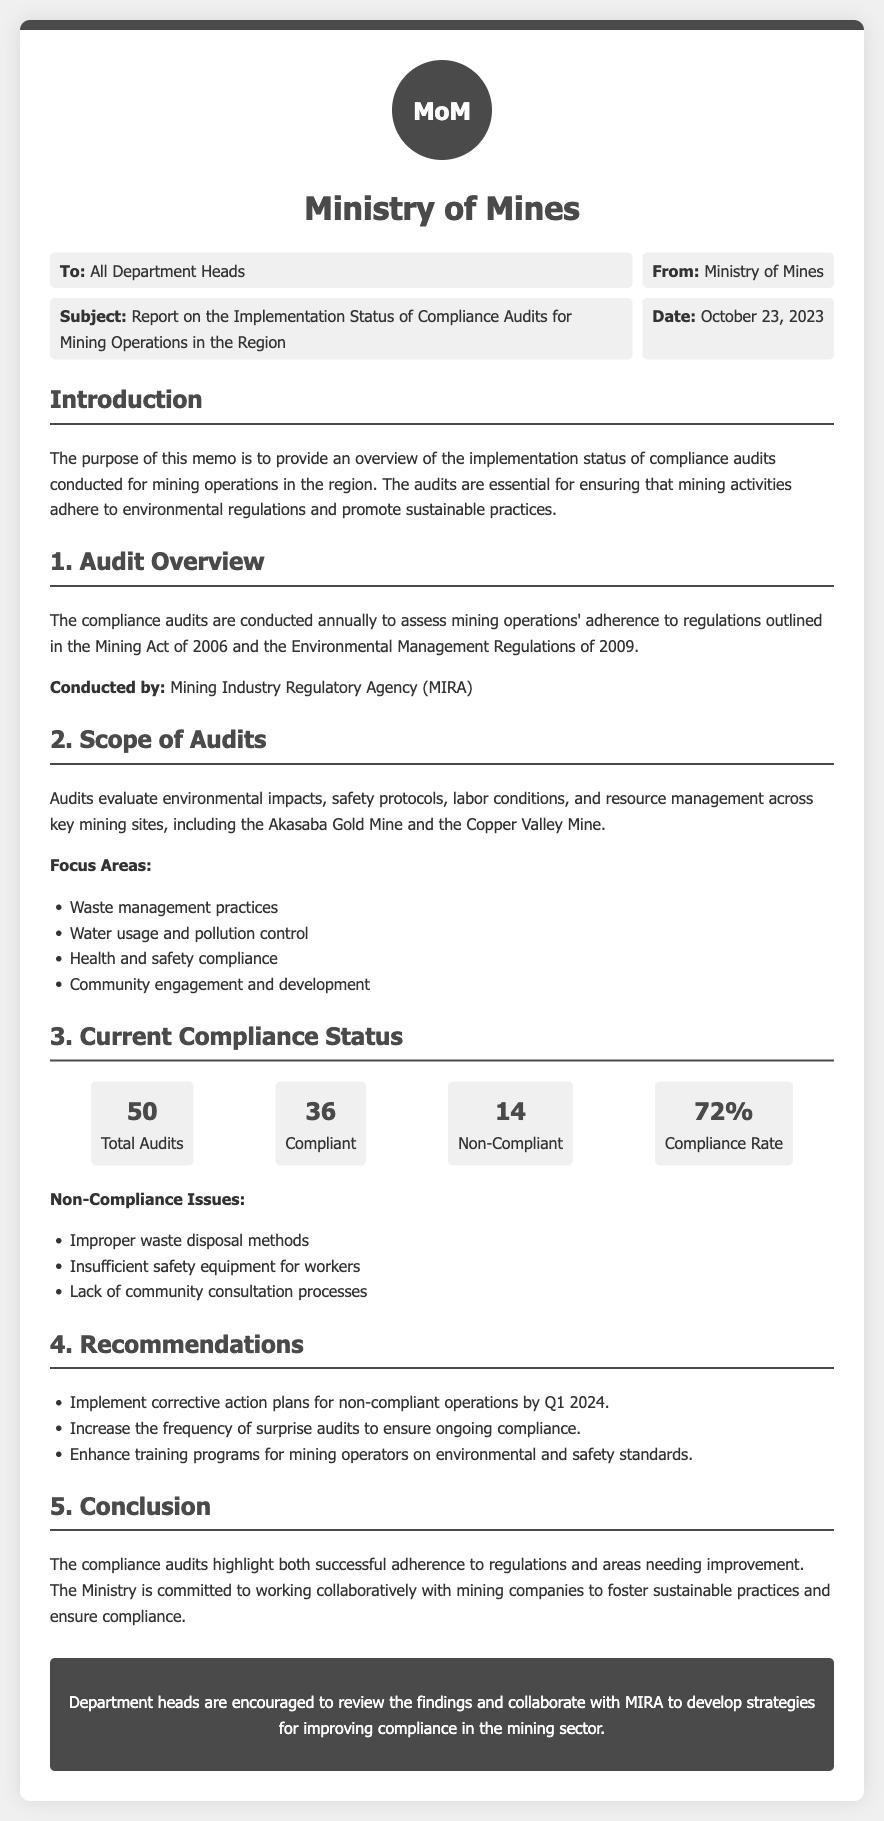What is the subject of the memo? The subject is stated in the meta section of the memo, which outlines the focus of the document.
Answer: Report on the Implementation Status of Compliance Audits for Mining Operations in the Region Who conducted the audits? The memo specifies that the audits are conducted by the Mining Industry Regulatory Agency.
Answer: Mining Industry Regulatory Agency (MIRA) What is the compliance rate? The compliance rate is provided in the current compliance status section of the memo.
Answer: 72% How many total audits were conducted? The total number of audits is mentioned in the current compliance status section.
Answer: 50 Name a non-compliance issue identified in the audits. The memo lists several non-compliance issues under the current compliance status section.
Answer: Improper waste disposal methods What is a recommended action for non-compliant operations? One of the recommendations given in the memo suggests specific actions for addressing non-compliance.
Answer: Implement corrective action plans for non-compliant operations by Q1 2024 Which year marks the regulations referenced in the compliance audits? The memo refers to two regulations with specific years that guide the compliance audits.
Answer: 2006 and 2009 What is the date of the memo? The date is mentioned in the meta section and indicates when the memo was written.
Answer: October 23, 2023 What is one of the focus areas of the audits? The memo lists several focus areas under the scope of audits, which highlight audit objectives.
Answer: Waste management practices 